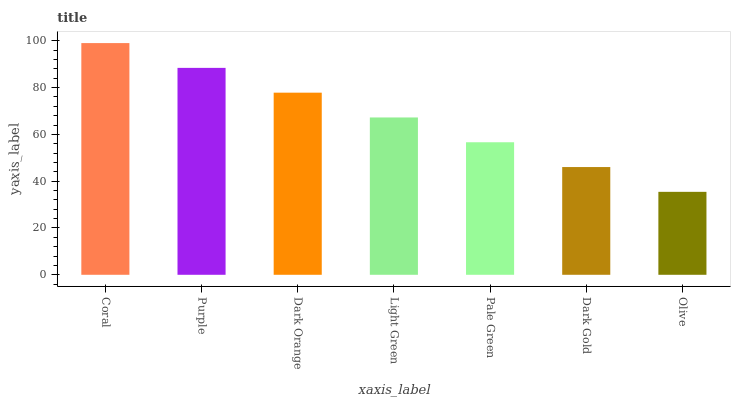Is Olive the minimum?
Answer yes or no. Yes. Is Coral the maximum?
Answer yes or no. Yes. Is Purple the minimum?
Answer yes or no. No. Is Purple the maximum?
Answer yes or no. No. Is Coral greater than Purple?
Answer yes or no. Yes. Is Purple less than Coral?
Answer yes or no. Yes. Is Purple greater than Coral?
Answer yes or no. No. Is Coral less than Purple?
Answer yes or no. No. Is Light Green the high median?
Answer yes or no. Yes. Is Light Green the low median?
Answer yes or no. Yes. Is Purple the high median?
Answer yes or no. No. Is Purple the low median?
Answer yes or no. No. 